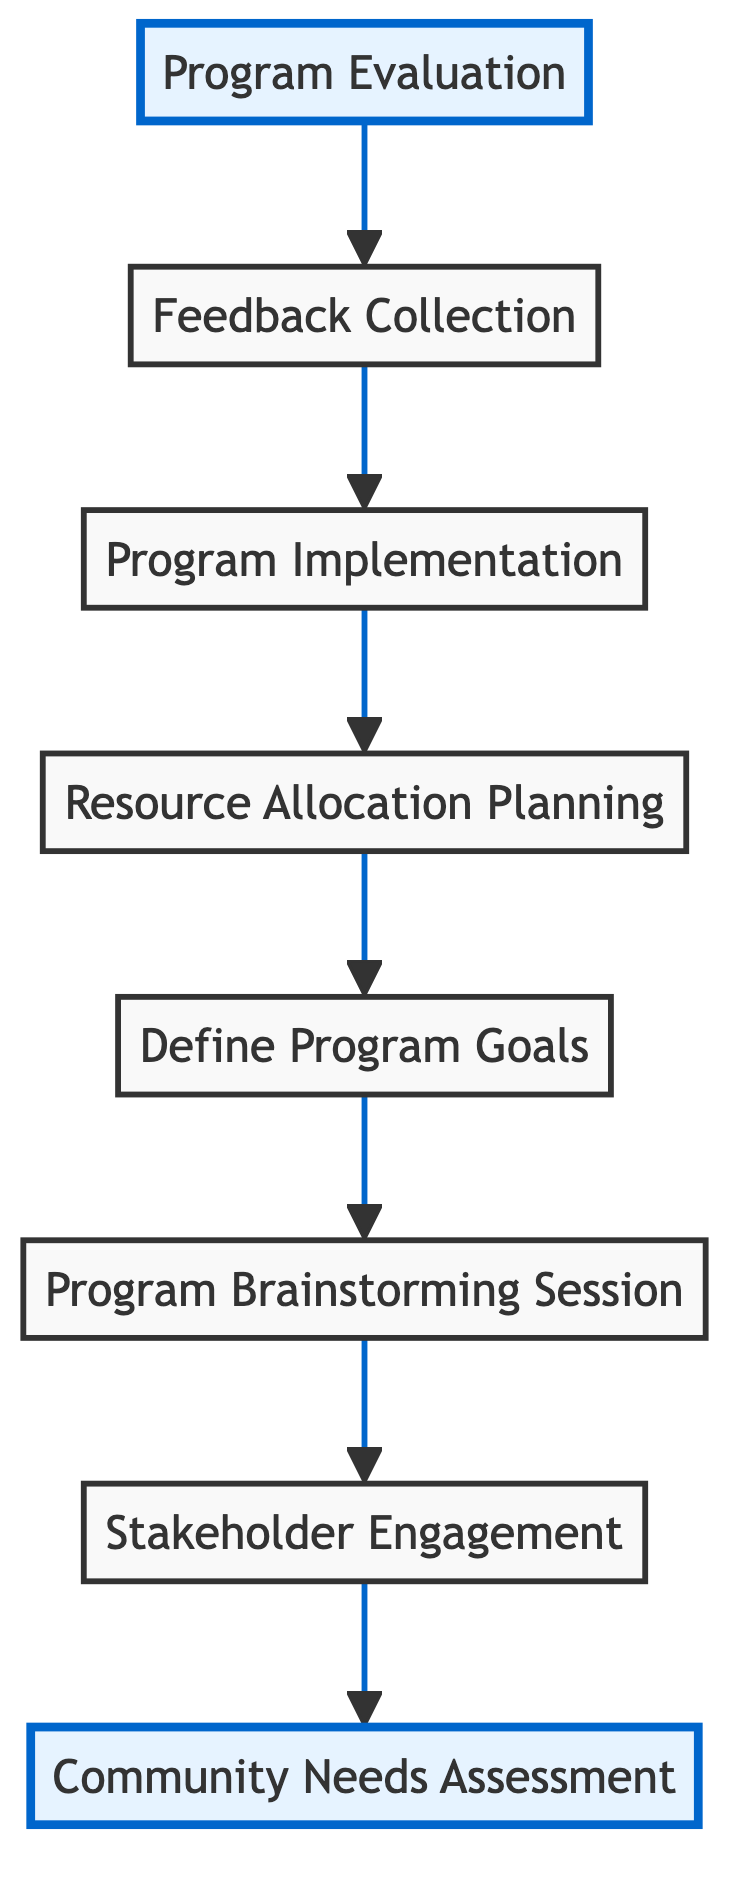What is the first step of the outreach program? The first step in the bottom-up flow chart is represented as node 1, which is "Community Needs Assessment." This is identified by the direction of the flow from node 1 at the bottom of the diagram, which leads to stakeholder engagement and subsequent steps.
Answer: Community Needs Assessment How many nodes are involved in the outreach program? By counting the total number of described steps or processes in the flow chart, we find there are 8 nodes, which include all elements from the community assessment to program evaluation.
Answer: 8 Which step comes right before "Program Implementation"? In the diagram, the flow shows a direct connection from "Resource Allocation Planning" (node 5) to "Program Implementation" (node 6). Therefore, the step just before "Program Implementation" is identified as "Resource Allocation Planning."
Answer: Resource Allocation Planning What is the last step of the outreach program? The last step in the flow, as indicated by node 8, is "Program Evaluation." The directional flow leads toward this final node, confirming it as the concluding action of the outreach initiative.
Answer: Program Evaluation Which two steps directly precede "Feedback Collection"? To understand the sequence leading to "Feedback Collection" (node 7), we follow the arrows from "Program Implementation" (node 6) and discover that it directly precedes node 7. The two steps leading up to it are "Program Implementation" and "Resource Allocation Planning." Therefore, both directly influence the feedback gathering process.
Answer: Program Implementation, Resource Allocation Planning What are the highlighted steps in the diagram? The highlighted steps in the flow chart are "Community Needs Assessment" (node 1) and "Program Evaluation" (node 8). These are visually distinguished to indicate their significance in the overall outreach process.
Answer: Community Needs Assessment, Program Evaluation Which step assesses program effectiveness? The step that evaluates the outreach program's effectiveness is "Program Evaluation" (node 8). This is confirmed as it specifically focuses on analyzing data collected from prior steps and determining the impact of the initiative.
Answer: Program Evaluation What connects the "Stakeholder Engagement" to "Community Needs Assessment"? "Stakeholder Engagement" (node 2) is connected to "Community Needs Assessment" (node 1) by the flow that traces back from 2 to 1, indicating it derives from the initial assessment of community needs.
Answer: The flow connection How many steps are there between "Program Brainstorming Session" and "Feedback Collection"? Counting the steps in the directional flow leads us from "Program Brainstorming Session" (node 3) to "Feedback Collection" (node 7). There are 4 steps in total that occur between these two nodes, which are "Define Program Goals," "Resource Allocation Planning," and "Program Implementation."
Answer: 4 